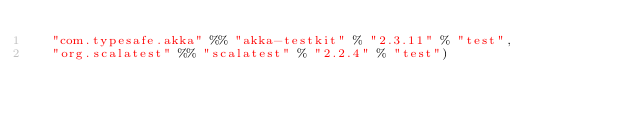Convert code to text. <code><loc_0><loc_0><loc_500><loc_500><_Scala_>  "com.typesafe.akka" %% "akka-testkit" % "2.3.11" % "test",
  "org.scalatest" %% "scalatest" % "2.2.4" % "test")
</code> 